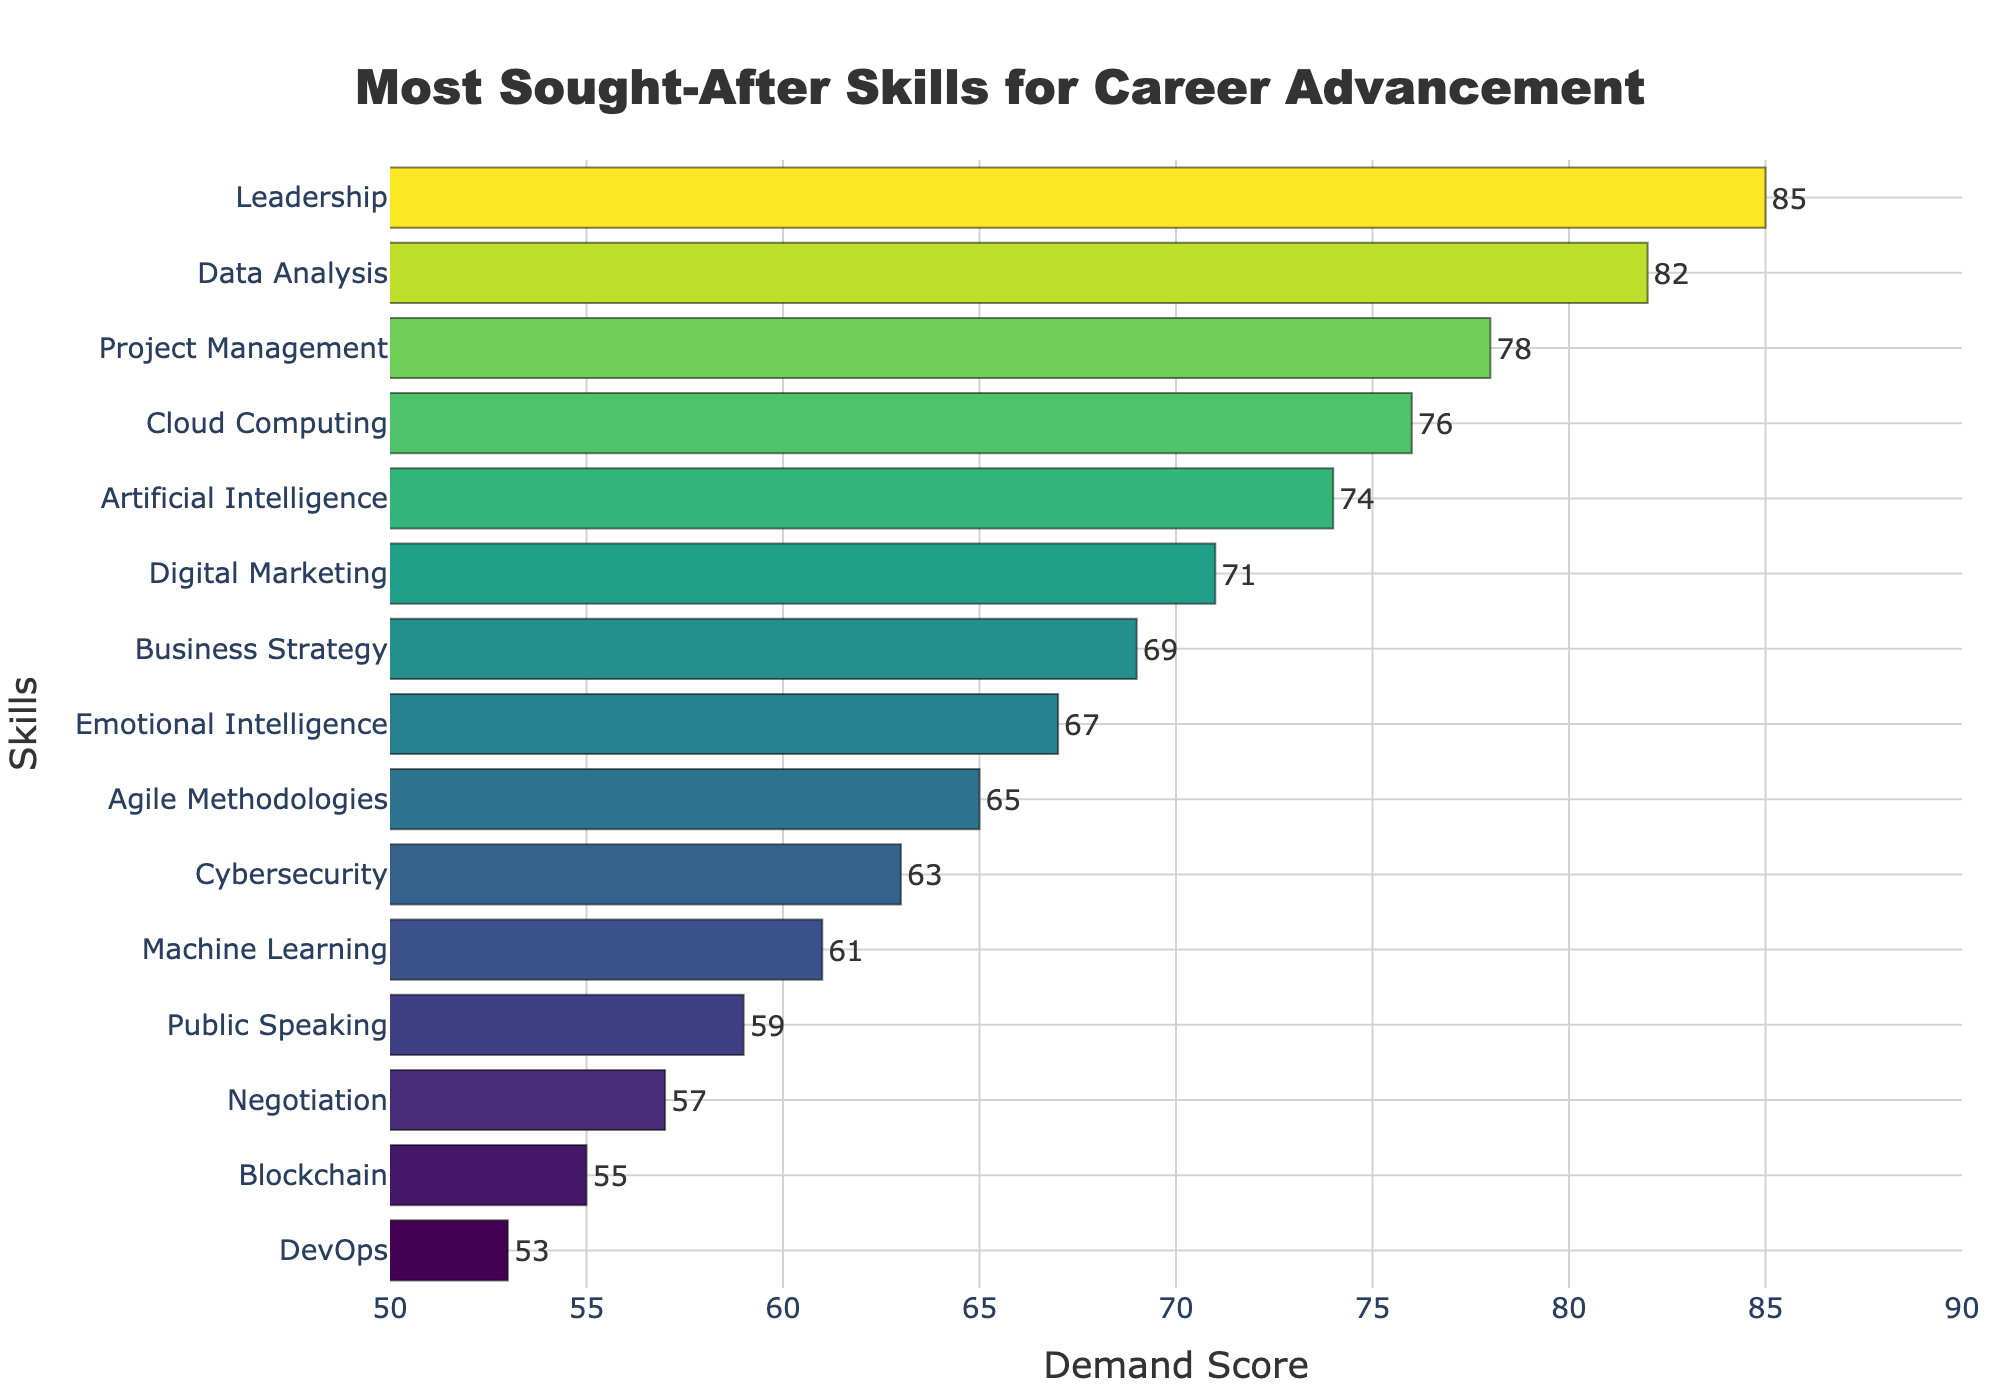what's the highest demand score among all the skills? The highest demand score can be found by looking at the value at the end of the longest bar in the chart. The longest bar corresponds to "Leadership" which has a demand score of 85.
Answer: 85 Which skill has a lower demand score, Data Analysis or Business Strategy? By comparing the lengths of the bars for "Data Analysis" and "Business Strategy," we can see that "Data Analysis" has a demand score of 82, whereas "Business Strategy" has a demand score of 69. Therefore, "Business Strategy" has the lower demand score.
Answer: Business Strategy What is the difference in demand score between Cloud Computing and Public Speaking? Check the demand scores for both "Cloud Computing" and "Public Speaking." "Cloud Computing" has a demand score of 76 and "Public Speaking" has a demand score of 59. Subtracting the two gives 76 - 59 = 17.
Answer: 17 How many skills have a demand score greater than 70? To determine the number of skills with a demand score greater than 70, visually identify and count the bars that extend beyond the 70 mark on the x-axis. The skills are Leadership, Data Analysis, Project Management, Cloud Computing, Artificial Intelligence, and Digital Marketing. There are 6 skills.
Answer: 6 Which skill is exactly in the middle of the demand score range? To find the median skill, list the demand scores in ascending order and find the middle value. The sorted demand scores are 53, 55, 57, 59, 61, 63, 65, 67, 69, 71, 74, 76, 78, 82, 85. The median score is the 8th value, which corresponds to Emotional Intelligence.
Answer: Emotional Intelligence What is the average demand score of the top 5 skills? Identify the top 5 skills based on their demand scores: Leadership (85), Data Analysis (82), Project Management (78), Cloud Computing (76), and Artificial Intelligence (74). Calculate the average by summing these scores and dividing by 5: (85 + 82 + 78 + 76 + 74) / 5 = 395 / 5 = 79.
Answer: 79 Is the demand score for Data Analysis greater than twice the demand score for Blockchain? Find the demand scores for Data Analysis and Blockchain. Data Analysis has a demand score of 82 and Blockchain has a demand score of 55. Calculate twice the Blockchain score: 2 * 55 = 110. Compare this with the Data Analysis score, 82 < 110, so it is not greater.
Answer: No Which skills have a demand score within 10 points of Agile Methodologies? Identify the demand scores for Agile Methodologies, which is 65. Skills within 10 points (55 to 75) are Blockchain (55), Negotiation (57), Public Speaking (59), Machine Learning (61), Cybersecurity (63), and Emotional Intelligence (67).
Answer: Blockchain, Negotiation, Public Speaking, Machine Learning, Cybersecurity, Emotional Intelligence 